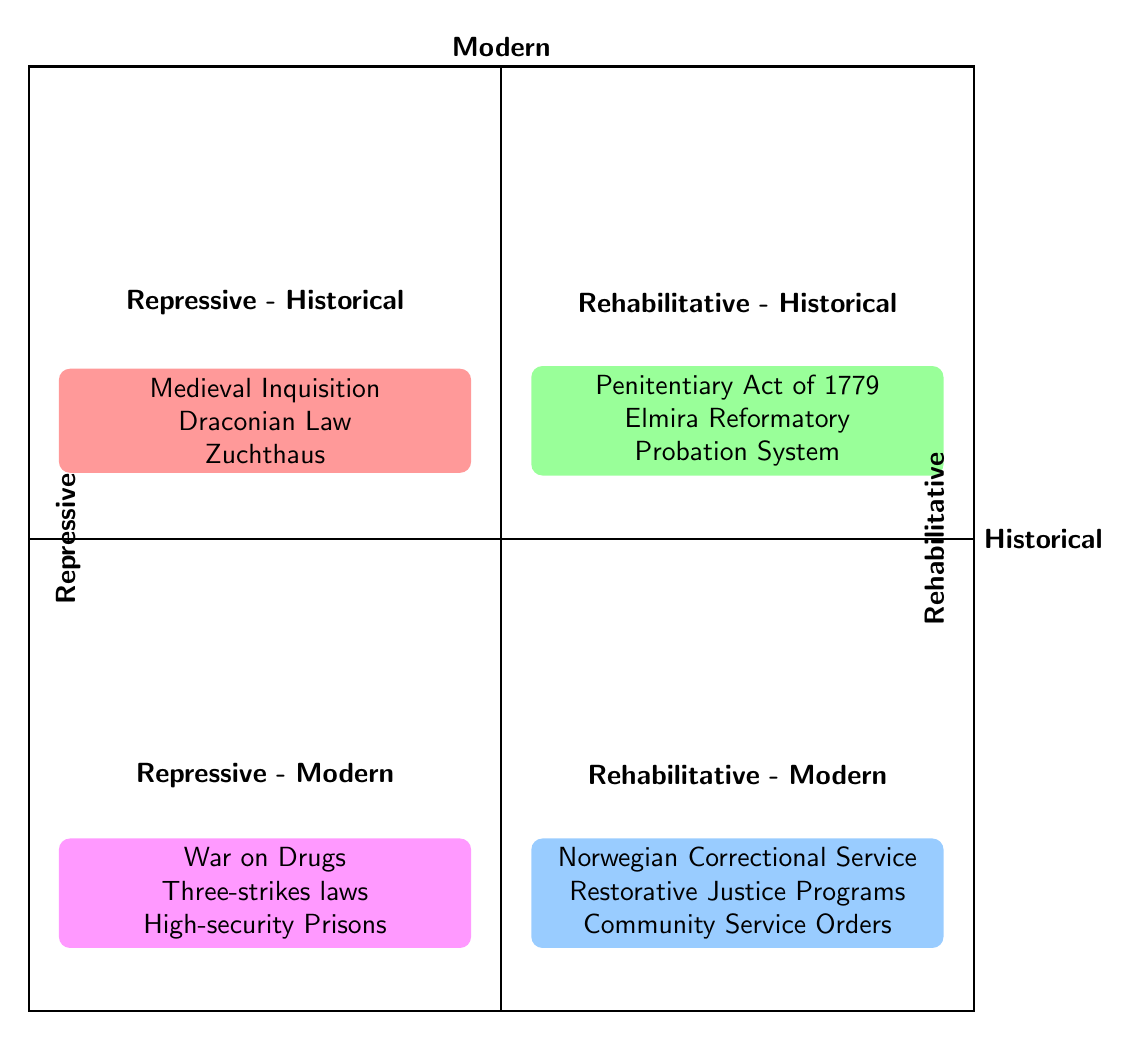What are three elements in the Repressive - Historical quadrant? The diagram lists "Medieval Inquisition," "Draconian Law," and "Zuchthaus (17th century German prisons)" as elements in the Repressive - Historical quadrant.
Answer: Medieval Inquisition, Draconian Law, Zuchthaus How many elements are in the Rehabilitative - Modern quadrant? The Rehabilitative - Modern quadrant contains three elements: "Norwegian Correctional Service," "Restorative Justice Programs," and "Community Service Orders." Thus, the total is three.
Answer: 3 What is a common approach found in both Repressive quadrants? The Repressive - Historical quadrant includes "Medieval Inquisition" and the Repressive - Modern quadrant includes "War on Drugs." Both are classified as repressive.
Answer: War on Drugs Which quadrant contains the "Penitentiary Act of 1779"? The "Penitentiary Act of 1779" is listed in the Rehabilitative - Historical quadrant, indicating it is a historical reform with rehabilitative intentions.
Answer: Rehabilitative - Historical What type of justice does the "Norwegian Correctional Service" represent? The "Norwegian Correctional Service" is categorized within the Rehabilitative - Modern quadrant, which indicates it represents a rehabilitative approach to criminal justice.
Answer: Rehabilitative What is one modern example of a repressive approach? The diagram cites "Three-strikes laws" as a modern example of a repressive approach within the Repressive - Modern quadrant.
Answer: Three-strikes laws How are elements categorized in this diagram? The diagram is divided into four quadrants based on the two axes: the x-axis represents the time period (Historical and Modern) while the y-axis differentiates the approaches (Repressive and Rehabilitative).
Answer: Four quadrants How many total quadrants are present in the diagram? There are a total of four quadrants depicted in the diagram: two for historical and two for modern approaches.
Answer: 4 